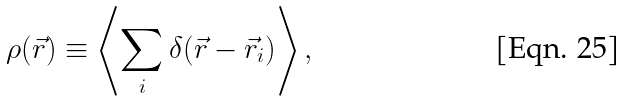Convert formula to latex. <formula><loc_0><loc_0><loc_500><loc_500>\rho ( \vec { r } ) \equiv \left \langle \sum _ { i } \delta ( \vec { r } - \vec { r } _ { i } ) \right \rangle ,</formula> 